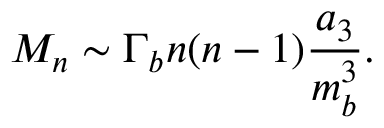Convert formula to latex. <formula><loc_0><loc_0><loc_500><loc_500>M _ { n } \sim \Gamma _ { b } n ( n - 1 ) \frac { a _ { 3 } } { m _ { b } ^ { 3 } } .</formula> 